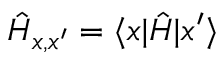Convert formula to latex. <formula><loc_0><loc_0><loc_500><loc_500>{ \hat { H } } _ { x , x ^ { \prime } } = \langle x | \hat { H } | x ^ { \prime } \rangle</formula> 